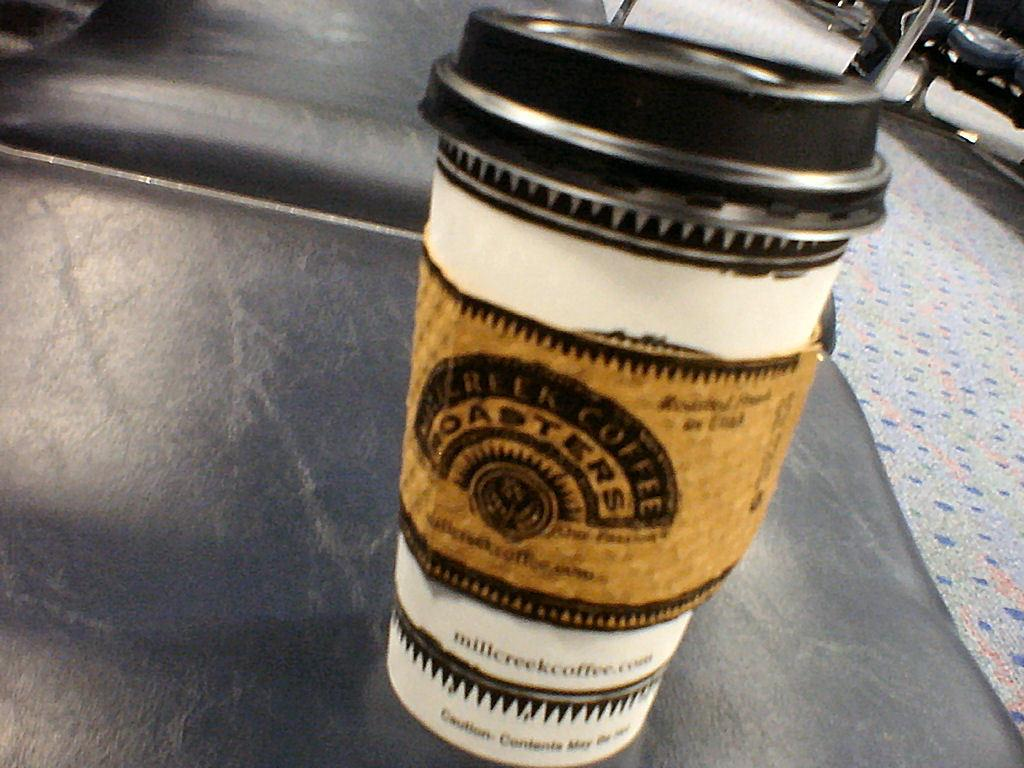What is the main object in the center of the image? There is a cup in the center of the image. Where is the cup located? The cup is on a table. What else can be seen in the image besides the cup? There are objects visible in the background, and the floor is visible in the image. Can you see a giraffe or a snake in the image? No, there are no giraffes or snakes present in the image. 